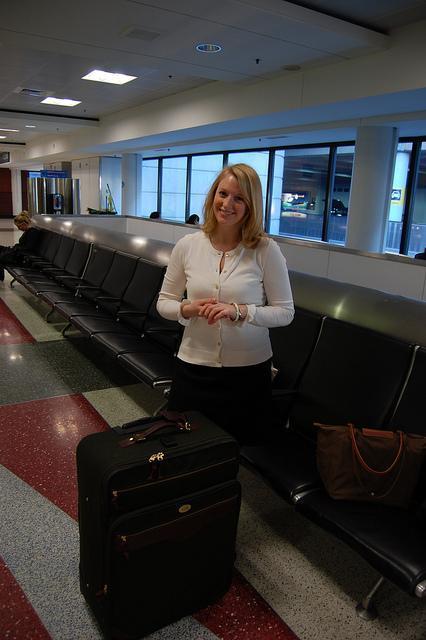How many bags does this woman have?
Give a very brief answer. 2. How many chairs can be seen?
Give a very brief answer. 5. How many boats are in front of the church?
Give a very brief answer. 0. 